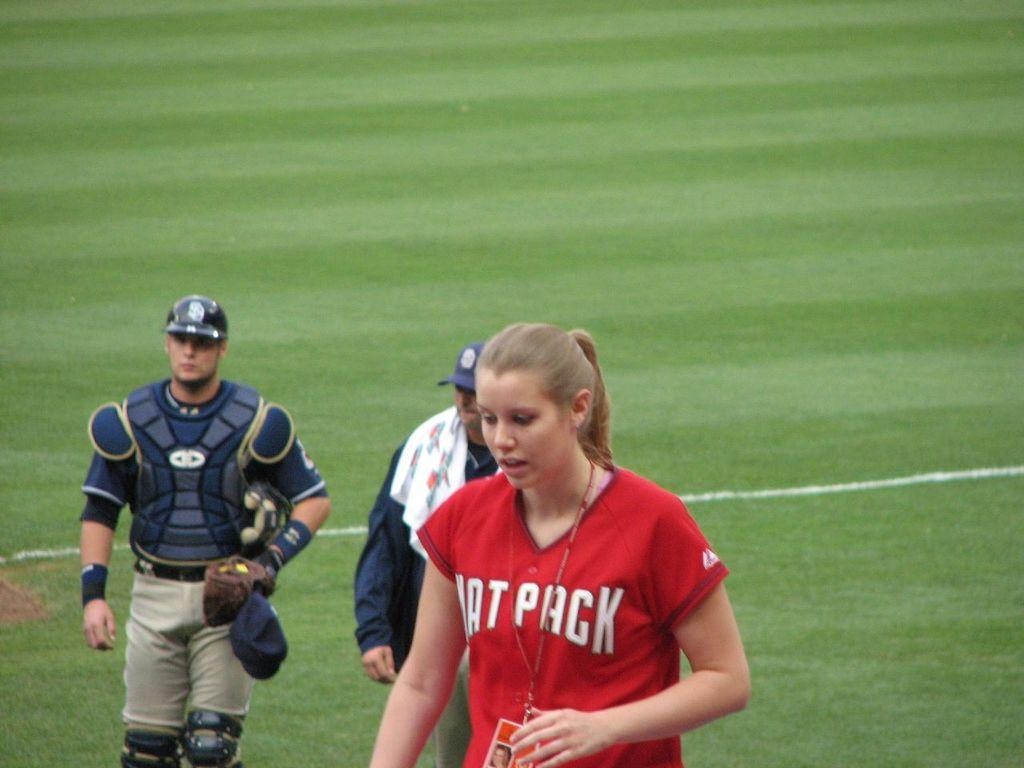<image>
Share a concise interpretation of the image provided. a lady that has the name pack on her jersey 